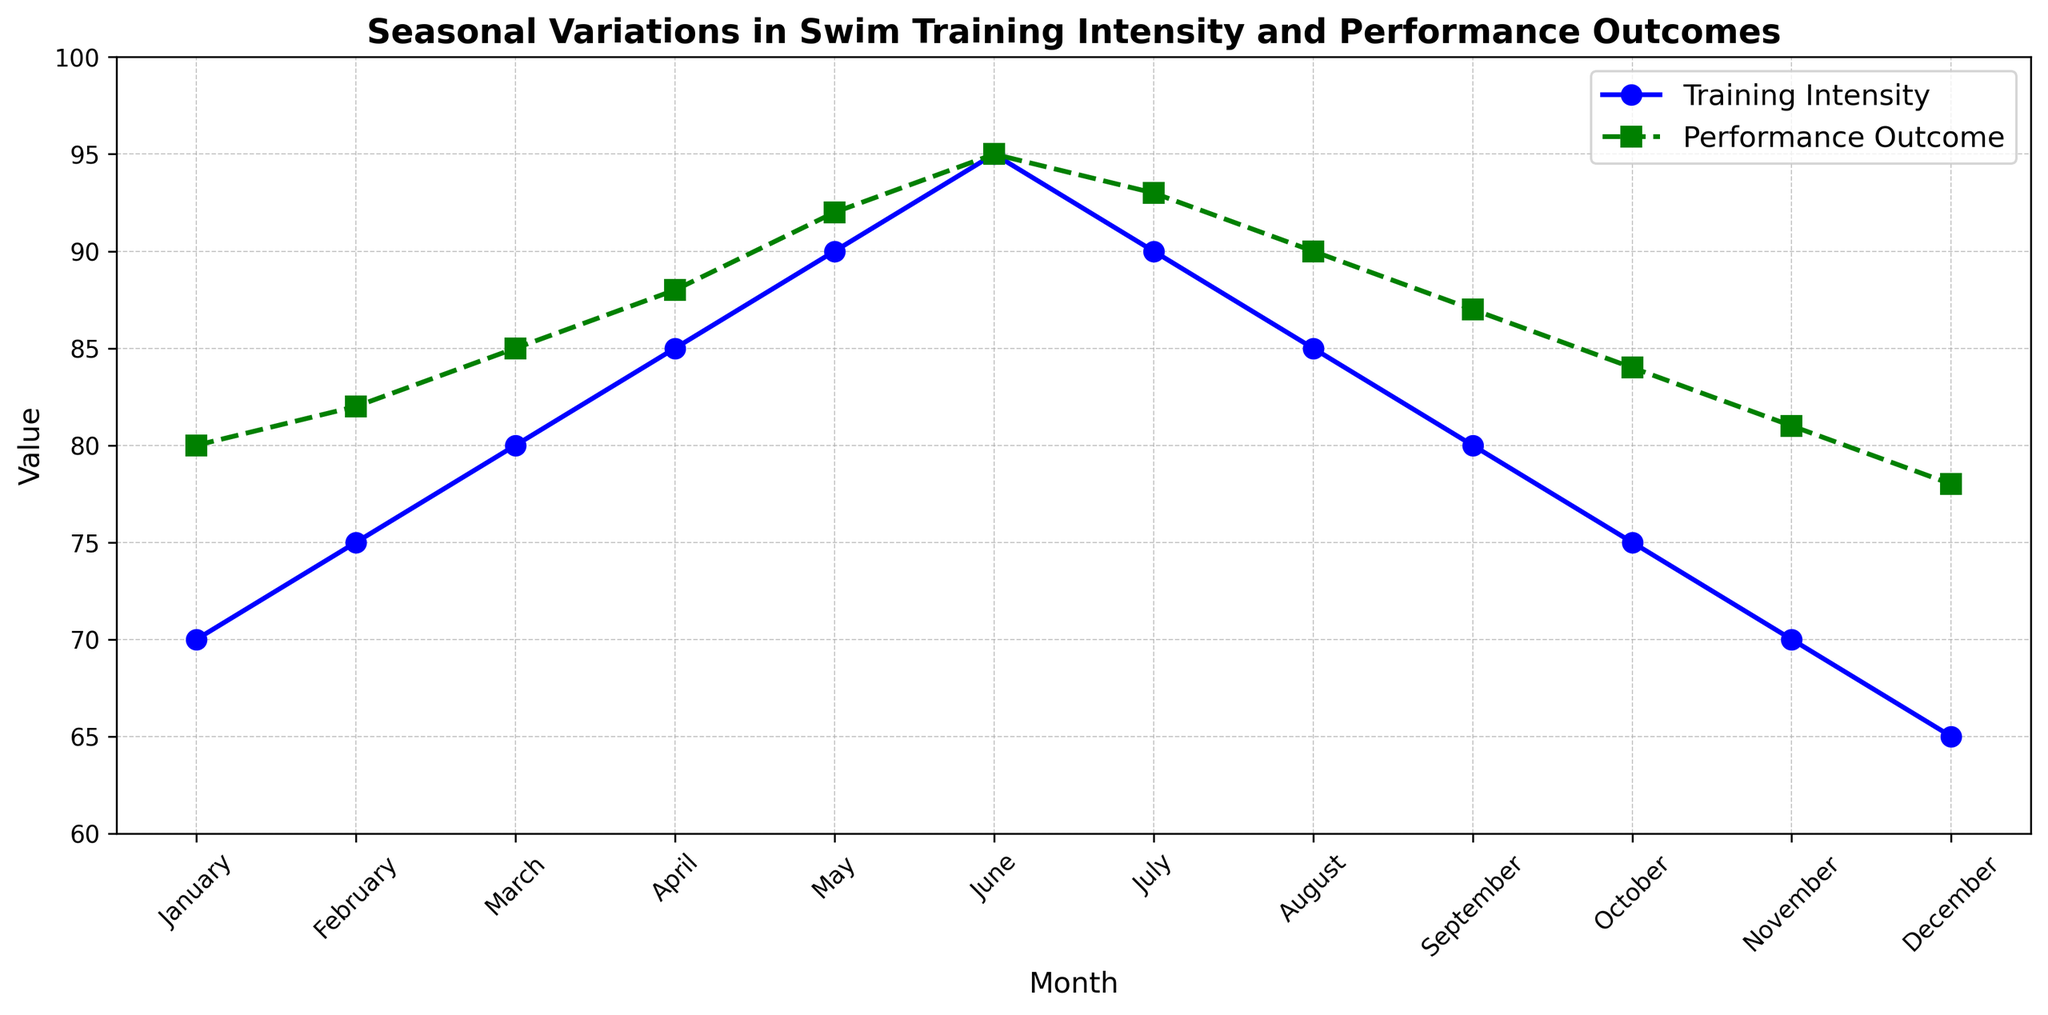What is the trend of Training Intensity over the months? To find the trend, observe the Training Intensity line in blue. The intensity starts at 70 in January, increases steadily to a peak of 95 in June, and then declines to 65 by December.
Answer: It increases until June, then decreases Which month shows the highest Performance Outcome? The Performance Outcome is represented by the green line. The highest value is 95, which occurs in June.
Answer: June What is the difference in Training Intensity between May and February? The Training Intensity in May is 90, and in February, it is 75. The difference is calculated by subtracting the February value from the May value: 90 - 75 = 15.
Answer: 15 In which month is the gap between Training Intensity and Performance Outcome the largest? To determine the gap, calculate the difference between the Training Intensity and Performance Outcome for each month. The largest gap is in January, where Training Intensity is 70 and Performance Outcome is 80, giving a gap of 10.
Answer: January Is there any month where the Training Intensity and Performance Outcome are equal? Scan the data points of both lines, looking for any intersections. June is the only month where both values are 95.
Answer: June During which months does the Training Intensity decline continuously? By examining the blue line, the Training Intensity declines continuously from June to December.
Answer: June to December What is the average Performance Outcome for the first half of the year? Calculate the average Performance Outcome from January to June: (80 + 82 + 85 + 88 + 92 + 95) / 6 = 522 / 6 = 87.
Answer: 87 How does the Performance Outcome in July compare to the Training Intensity in the same month? In July, Performance Outcome is 93, and Training Intensity is 90. Performance Outcome is higher.
Answer: Performance Outcome is higher What is the total increase in Training Intensity from January to June? Calculate the increase month by month: (75-70) + (80-75) + (85-80) + (90-85) + (95-90) = 5 + 5 + 5 + 5 + 5 = 25.
Answer: 25 Compare the downward trends of Training Intensity and Performance Outcome from August to December. From August to December, Training Intensity declines from 85 to 65, a drop of 20 units. Performance Outcome declines from 90 to 78, a drop of 12 units. Training Intensity has a steeper decline.
Answer: Training Intensity has a steeper decline 